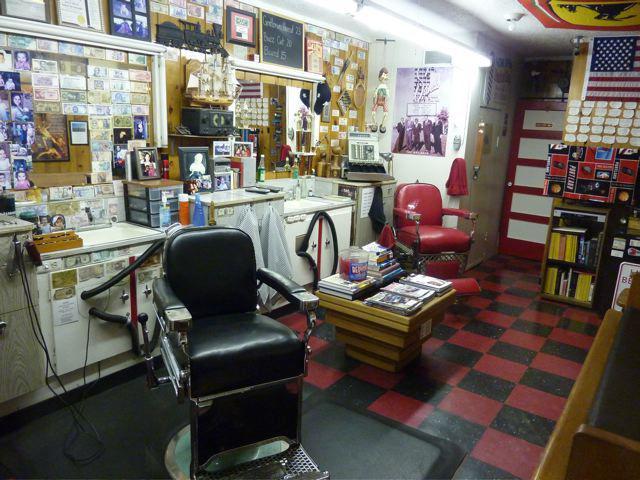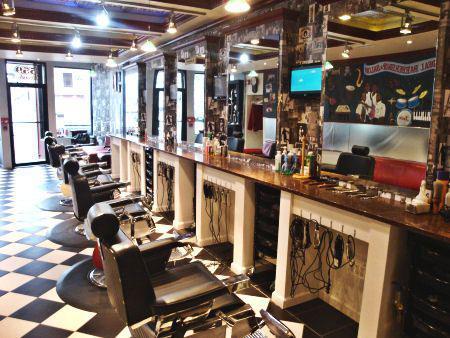The first image is the image on the left, the second image is the image on the right. For the images shown, is this caption "The image on the right contains at least one person." true? Answer yes or no. No. 